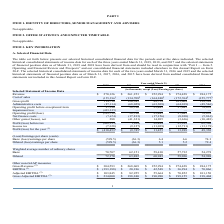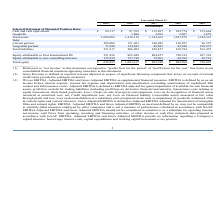According to Eros International Plc's financial document, What is the definition of EBITDA as per the company? EBITDA is defined by us as net income before interest expense, income tax expense and depreciation and amortization (excluding amortization of capitalized film content and debt issuance costs).. The document states: "djusted EBITDA as supplemental financial measures. EBITDA is defined by us as net income before interest expense, income tax expense and depreciation ..." Also, What information do EBITDA and Adjusted EBITDA provide regarding company's capital structure? EBITDA, Adjusted EBITDA and Gross Adjusted EBITDA provide no information regarding a Company’s capital structure, borrowings, interest costs, capital expenditures and working capital movement or tax position.. The document states: "w statement data prepared in accordance with GAAP. EBITDA, Adjusted EBITDA and Gross Adjusted EBITDA provide no information regarding a Company’s capi..." Also, What are the years included in the table? The document contains multiple relevant values: 2019, 2018, 2017, 2016, 2015. From the document: "2019 2018 2017 2016 2015 2019 2018 2017 2016 2015 2019 2018 2017 2016 2015 2019 2018 2017 2016 2015 2019 2018 2017 2016 2015..." Also, can you calculate: What is the increase / (decrease) in revenue from 2018 to 2019? Based on the calculation: 270,126 - 261,253, the result is 8873 (in thousands). This is based on the information: "Selected Statement of Income Data Revenue $ 270,126 $ 261,253 $ 252,994 $ 274,428 $ 284,175 cted Statement of Income Data Revenue $ 270,126 $ 261,253 $ 252,994 $ 274,428 $ 284,175..." The key data points involved are: 261,253, 270,126. Also, can you calculate: What is the average gross profit? To answer this question, I need to perform calculations using the financial data. The calculation is: (114,730 + 126,545 + 88,754 + 101,664 + 128,398) / 5, which equals 112018.2 (in thousands). This is based on the information: "Gross profit 114,730 126,545 88,754 101,664 128,398 Gross profit 114,730 126,545 88,754 101,664 128,398 Gross profit 114,730 126,545 88,754 101,664 128,398 Gross profit 114,730 126,545 88,754 101,664 ..." The key data points involved are: 101,664, 114,730, 126,545. Also, can you calculate: What is the percentage increase / (decrease) in the Operating profit before exceptional item from 2018 to 2019? To answer this question, I need to perform calculations using the financial data. The calculation is: 27,596 / 58,516 - 1, which equals -52.84 (percentage). This is based on the information: "Operating profit before exceptional item 27,596 58,516 25,445 37,645 78,852 Operating profit before exceptional item 27,596 58,516 25,445 37,645 78,852..." The key data points involved are: 27,596, 58,516. 